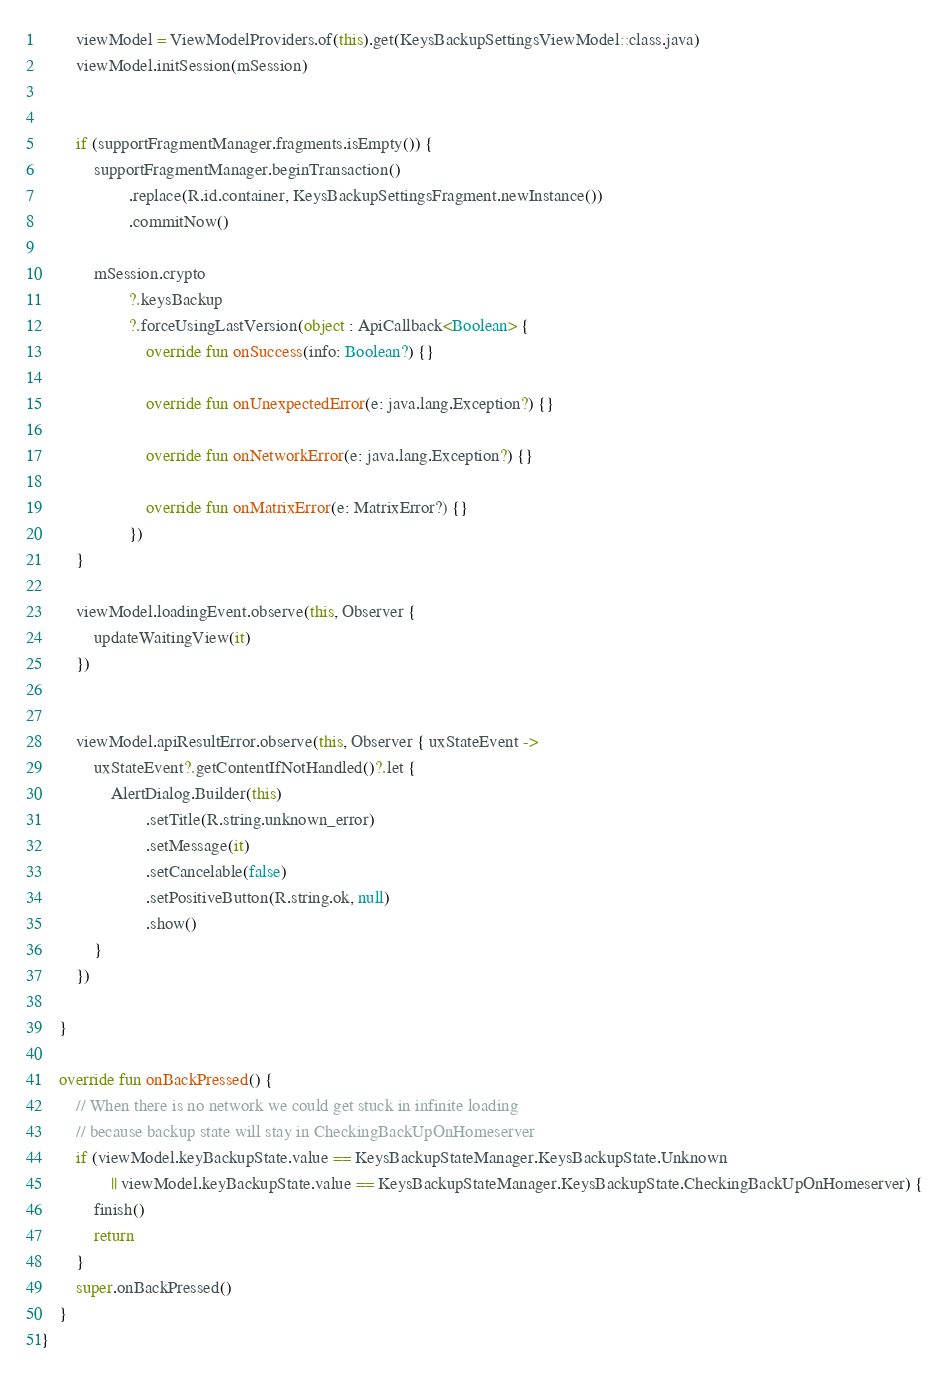Convert code to text. <code><loc_0><loc_0><loc_500><loc_500><_Kotlin_>        viewModel = ViewModelProviders.of(this).get(KeysBackupSettingsViewModel::class.java)
        viewModel.initSession(mSession)


        if (supportFragmentManager.fragments.isEmpty()) {
            supportFragmentManager.beginTransaction()
                    .replace(R.id.container, KeysBackupSettingsFragment.newInstance())
                    .commitNow()

            mSession.crypto
                    ?.keysBackup
                    ?.forceUsingLastVersion(object : ApiCallback<Boolean> {
                        override fun onSuccess(info: Boolean?) {}

                        override fun onUnexpectedError(e: java.lang.Exception?) {}

                        override fun onNetworkError(e: java.lang.Exception?) {}

                        override fun onMatrixError(e: MatrixError?) {}
                    })
        }

        viewModel.loadingEvent.observe(this, Observer {
            updateWaitingView(it)
        })


        viewModel.apiResultError.observe(this, Observer { uxStateEvent ->
            uxStateEvent?.getContentIfNotHandled()?.let {
                AlertDialog.Builder(this)
                        .setTitle(R.string.unknown_error)
                        .setMessage(it)
                        .setCancelable(false)
                        .setPositiveButton(R.string.ok, null)
                        .show()
            }
        })

    }

    override fun onBackPressed() {
        // When there is no network we could get stuck in infinite loading
        // because backup state will stay in CheckingBackUpOnHomeserver
        if (viewModel.keyBackupState.value == KeysBackupStateManager.KeysBackupState.Unknown
                || viewModel.keyBackupState.value == KeysBackupStateManager.KeysBackupState.CheckingBackUpOnHomeserver) {
            finish()
            return
        }
        super.onBackPressed()
    }
}</code> 